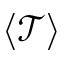Convert formula to latex. <formula><loc_0><loc_0><loc_500><loc_500>\langle \mathcal { T } \rangle</formula> 